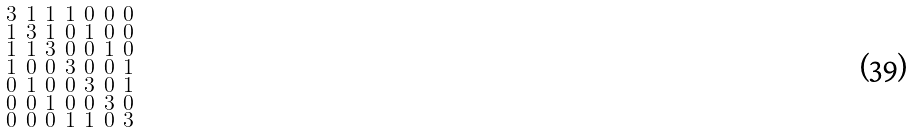<formula> <loc_0><loc_0><loc_500><loc_500>\begin{smallmatrix} 3 & 1 & 1 & 1 & 0 & 0 & 0 \\ 1 & 3 & 1 & 0 & 1 & 0 & 0 \\ 1 & 1 & 3 & 0 & 0 & 1 & 0 \\ 1 & 0 & 0 & 3 & 0 & 0 & 1 \\ 0 & 1 & 0 & 0 & 3 & 0 & 1 \\ 0 & 0 & 1 & 0 & 0 & 3 & 0 \\ 0 & 0 & 0 & 1 & 1 & 0 & 3 \end{smallmatrix}</formula> 